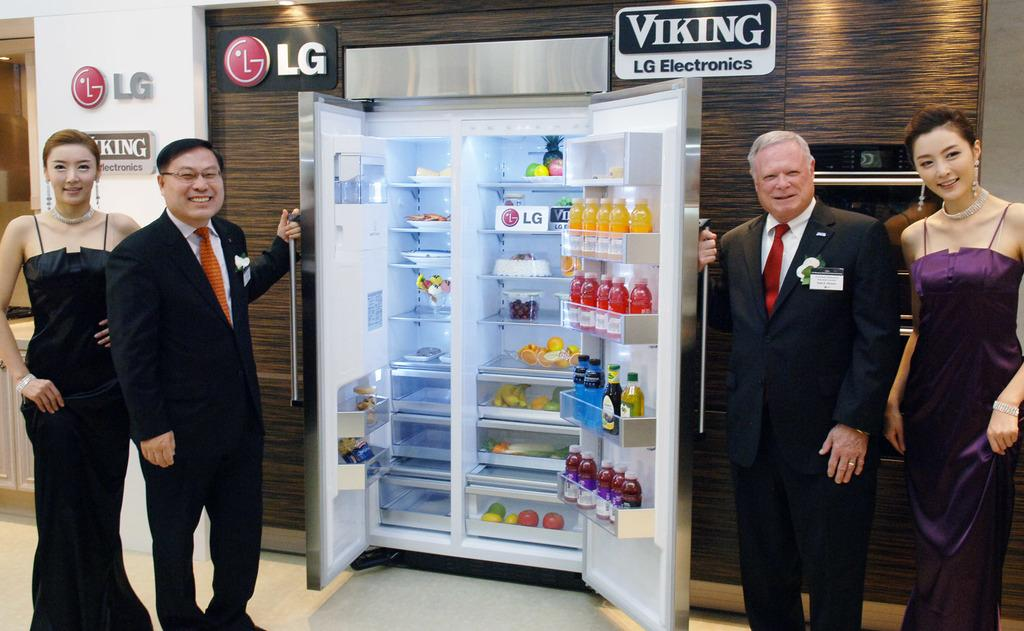<image>
Create a compact narrative representing the image presented. The manufacture of the refrigerator was Viking LG. 